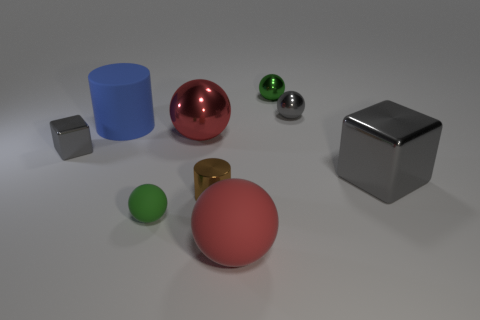Subtract all gray balls. How many balls are left? 4 Subtract all small gray metallic spheres. How many spheres are left? 4 Subtract all brown balls. Subtract all blue cubes. How many balls are left? 5 Add 1 gray blocks. How many objects exist? 10 Subtract all cubes. How many objects are left? 7 Subtract all red balls. Subtract all rubber cylinders. How many objects are left? 6 Add 6 big blue matte objects. How many big blue matte objects are left? 7 Add 9 large rubber balls. How many large rubber balls exist? 10 Subtract 0 brown cubes. How many objects are left? 9 